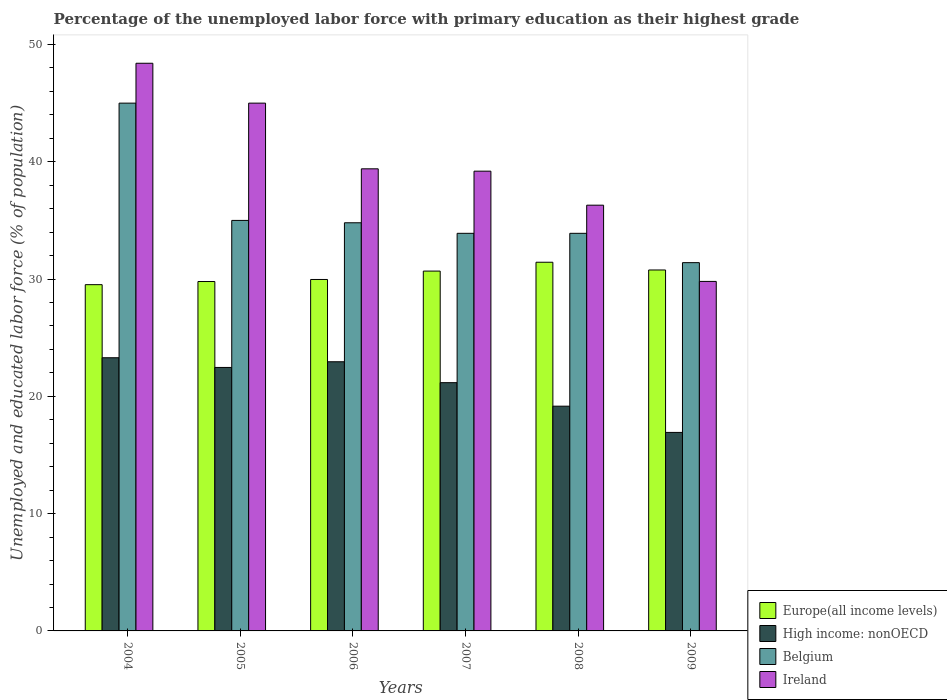Are the number of bars per tick equal to the number of legend labels?
Provide a short and direct response. Yes. Are the number of bars on each tick of the X-axis equal?
Offer a very short reply. Yes. How many bars are there on the 4th tick from the right?
Provide a short and direct response. 4. What is the label of the 3rd group of bars from the left?
Offer a very short reply. 2006. In how many cases, is the number of bars for a given year not equal to the number of legend labels?
Ensure brevity in your answer.  0. What is the percentage of the unemployed labor force with primary education in High income: nonOECD in 2004?
Your response must be concise. 23.29. Across all years, what is the maximum percentage of the unemployed labor force with primary education in High income: nonOECD?
Keep it short and to the point. 23.29. Across all years, what is the minimum percentage of the unemployed labor force with primary education in Europe(all income levels)?
Ensure brevity in your answer.  29.52. In which year was the percentage of the unemployed labor force with primary education in Ireland minimum?
Provide a succinct answer. 2009. What is the total percentage of the unemployed labor force with primary education in Belgium in the graph?
Your answer should be very brief. 214. What is the difference between the percentage of the unemployed labor force with primary education in Ireland in 2004 and that in 2008?
Your answer should be compact. 12.1. What is the difference between the percentage of the unemployed labor force with primary education in Europe(all income levels) in 2008 and the percentage of the unemployed labor force with primary education in Ireland in 2006?
Ensure brevity in your answer.  -7.97. What is the average percentage of the unemployed labor force with primary education in Ireland per year?
Keep it short and to the point. 39.68. In the year 2009, what is the difference between the percentage of the unemployed labor force with primary education in Europe(all income levels) and percentage of the unemployed labor force with primary education in Ireland?
Your response must be concise. 0.97. In how many years, is the percentage of the unemployed labor force with primary education in Europe(all income levels) greater than 46 %?
Give a very brief answer. 0. What is the ratio of the percentage of the unemployed labor force with primary education in Ireland in 2004 to that in 2005?
Offer a terse response. 1.08. Is the percentage of the unemployed labor force with primary education in High income: nonOECD in 2006 less than that in 2009?
Keep it short and to the point. No. Is the difference between the percentage of the unemployed labor force with primary education in Europe(all income levels) in 2004 and 2005 greater than the difference between the percentage of the unemployed labor force with primary education in Ireland in 2004 and 2005?
Provide a short and direct response. No. What is the difference between the highest and the second highest percentage of the unemployed labor force with primary education in Europe(all income levels)?
Offer a terse response. 0.66. What is the difference between the highest and the lowest percentage of the unemployed labor force with primary education in Ireland?
Give a very brief answer. 18.6. What does the 1st bar from the right in 2008 represents?
Keep it short and to the point. Ireland. How many bars are there?
Give a very brief answer. 24. What is the difference between two consecutive major ticks on the Y-axis?
Your answer should be compact. 10. Does the graph contain any zero values?
Provide a succinct answer. No. Does the graph contain grids?
Your answer should be compact. No. How many legend labels are there?
Make the answer very short. 4. What is the title of the graph?
Your response must be concise. Percentage of the unemployed labor force with primary education as their highest grade. What is the label or title of the X-axis?
Provide a short and direct response. Years. What is the label or title of the Y-axis?
Your answer should be very brief. Unemployed and educated labor force (% of population). What is the Unemployed and educated labor force (% of population) in Europe(all income levels) in 2004?
Your response must be concise. 29.52. What is the Unemployed and educated labor force (% of population) of High income: nonOECD in 2004?
Provide a short and direct response. 23.29. What is the Unemployed and educated labor force (% of population) of Belgium in 2004?
Your answer should be compact. 45. What is the Unemployed and educated labor force (% of population) of Ireland in 2004?
Ensure brevity in your answer.  48.4. What is the Unemployed and educated labor force (% of population) of Europe(all income levels) in 2005?
Provide a succinct answer. 29.79. What is the Unemployed and educated labor force (% of population) of High income: nonOECD in 2005?
Make the answer very short. 22.46. What is the Unemployed and educated labor force (% of population) of Belgium in 2005?
Keep it short and to the point. 35. What is the Unemployed and educated labor force (% of population) in Europe(all income levels) in 2006?
Keep it short and to the point. 29.97. What is the Unemployed and educated labor force (% of population) in High income: nonOECD in 2006?
Provide a short and direct response. 22.95. What is the Unemployed and educated labor force (% of population) in Belgium in 2006?
Make the answer very short. 34.8. What is the Unemployed and educated labor force (% of population) in Ireland in 2006?
Your answer should be compact. 39.4. What is the Unemployed and educated labor force (% of population) of Europe(all income levels) in 2007?
Offer a very short reply. 30.68. What is the Unemployed and educated labor force (% of population) of High income: nonOECD in 2007?
Your answer should be compact. 21.17. What is the Unemployed and educated labor force (% of population) of Belgium in 2007?
Provide a succinct answer. 33.9. What is the Unemployed and educated labor force (% of population) of Ireland in 2007?
Make the answer very short. 39.2. What is the Unemployed and educated labor force (% of population) of Europe(all income levels) in 2008?
Offer a terse response. 31.43. What is the Unemployed and educated labor force (% of population) of High income: nonOECD in 2008?
Give a very brief answer. 19.16. What is the Unemployed and educated labor force (% of population) in Belgium in 2008?
Make the answer very short. 33.9. What is the Unemployed and educated labor force (% of population) in Ireland in 2008?
Provide a succinct answer. 36.3. What is the Unemployed and educated labor force (% of population) in Europe(all income levels) in 2009?
Your answer should be compact. 30.77. What is the Unemployed and educated labor force (% of population) in High income: nonOECD in 2009?
Ensure brevity in your answer.  16.93. What is the Unemployed and educated labor force (% of population) of Belgium in 2009?
Your answer should be compact. 31.4. What is the Unemployed and educated labor force (% of population) of Ireland in 2009?
Your response must be concise. 29.8. Across all years, what is the maximum Unemployed and educated labor force (% of population) of Europe(all income levels)?
Your answer should be compact. 31.43. Across all years, what is the maximum Unemployed and educated labor force (% of population) of High income: nonOECD?
Provide a succinct answer. 23.29. Across all years, what is the maximum Unemployed and educated labor force (% of population) in Belgium?
Make the answer very short. 45. Across all years, what is the maximum Unemployed and educated labor force (% of population) in Ireland?
Give a very brief answer. 48.4. Across all years, what is the minimum Unemployed and educated labor force (% of population) of Europe(all income levels)?
Your response must be concise. 29.52. Across all years, what is the minimum Unemployed and educated labor force (% of population) of High income: nonOECD?
Keep it short and to the point. 16.93. Across all years, what is the minimum Unemployed and educated labor force (% of population) in Belgium?
Provide a short and direct response. 31.4. Across all years, what is the minimum Unemployed and educated labor force (% of population) in Ireland?
Provide a short and direct response. 29.8. What is the total Unemployed and educated labor force (% of population) of Europe(all income levels) in the graph?
Provide a succinct answer. 182.17. What is the total Unemployed and educated labor force (% of population) of High income: nonOECD in the graph?
Provide a short and direct response. 125.96. What is the total Unemployed and educated labor force (% of population) in Belgium in the graph?
Keep it short and to the point. 214. What is the total Unemployed and educated labor force (% of population) of Ireland in the graph?
Provide a succinct answer. 238.1. What is the difference between the Unemployed and educated labor force (% of population) in Europe(all income levels) in 2004 and that in 2005?
Your response must be concise. -0.27. What is the difference between the Unemployed and educated labor force (% of population) in High income: nonOECD in 2004 and that in 2005?
Give a very brief answer. 0.83. What is the difference between the Unemployed and educated labor force (% of population) of Belgium in 2004 and that in 2005?
Your answer should be very brief. 10. What is the difference between the Unemployed and educated labor force (% of population) of Ireland in 2004 and that in 2005?
Offer a terse response. 3.4. What is the difference between the Unemployed and educated labor force (% of population) in Europe(all income levels) in 2004 and that in 2006?
Provide a succinct answer. -0.44. What is the difference between the Unemployed and educated labor force (% of population) in High income: nonOECD in 2004 and that in 2006?
Your response must be concise. 0.34. What is the difference between the Unemployed and educated labor force (% of population) of Belgium in 2004 and that in 2006?
Offer a very short reply. 10.2. What is the difference between the Unemployed and educated labor force (% of population) in Europe(all income levels) in 2004 and that in 2007?
Your response must be concise. -1.16. What is the difference between the Unemployed and educated labor force (% of population) of High income: nonOECD in 2004 and that in 2007?
Offer a very short reply. 2.12. What is the difference between the Unemployed and educated labor force (% of population) in Belgium in 2004 and that in 2007?
Provide a succinct answer. 11.1. What is the difference between the Unemployed and educated labor force (% of population) of Europe(all income levels) in 2004 and that in 2008?
Provide a short and direct response. -1.91. What is the difference between the Unemployed and educated labor force (% of population) of High income: nonOECD in 2004 and that in 2008?
Give a very brief answer. 4.13. What is the difference between the Unemployed and educated labor force (% of population) of Belgium in 2004 and that in 2008?
Your response must be concise. 11.1. What is the difference between the Unemployed and educated labor force (% of population) of Europe(all income levels) in 2004 and that in 2009?
Offer a terse response. -1.25. What is the difference between the Unemployed and educated labor force (% of population) of High income: nonOECD in 2004 and that in 2009?
Your answer should be compact. 6.37. What is the difference between the Unemployed and educated labor force (% of population) in Ireland in 2004 and that in 2009?
Provide a succinct answer. 18.6. What is the difference between the Unemployed and educated labor force (% of population) in Europe(all income levels) in 2005 and that in 2006?
Provide a succinct answer. -0.17. What is the difference between the Unemployed and educated labor force (% of population) in High income: nonOECD in 2005 and that in 2006?
Ensure brevity in your answer.  -0.49. What is the difference between the Unemployed and educated labor force (% of population) of Ireland in 2005 and that in 2006?
Your answer should be very brief. 5.6. What is the difference between the Unemployed and educated labor force (% of population) in Europe(all income levels) in 2005 and that in 2007?
Your response must be concise. -0.89. What is the difference between the Unemployed and educated labor force (% of population) in High income: nonOECD in 2005 and that in 2007?
Your answer should be very brief. 1.3. What is the difference between the Unemployed and educated labor force (% of population) of Europe(all income levels) in 2005 and that in 2008?
Make the answer very short. -1.64. What is the difference between the Unemployed and educated labor force (% of population) in High income: nonOECD in 2005 and that in 2008?
Give a very brief answer. 3.3. What is the difference between the Unemployed and educated labor force (% of population) of Belgium in 2005 and that in 2008?
Your response must be concise. 1.1. What is the difference between the Unemployed and educated labor force (% of population) of Europe(all income levels) in 2005 and that in 2009?
Provide a succinct answer. -0.98. What is the difference between the Unemployed and educated labor force (% of population) in High income: nonOECD in 2005 and that in 2009?
Keep it short and to the point. 5.54. What is the difference between the Unemployed and educated labor force (% of population) of Belgium in 2005 and that in 2009?
Your answer should be very brief. 3.6. What is the difference between the Unemployed and educated labor force (% of population) in Europe(all income levels) in 2006 and that in 2007?
Keep it short and to the point. -0.71. What is the difference between the Unemployed and educated labor force (% of population) of High income: nonOECD in 2006 and that in 2007?
Keep it short and to the point. 1.78. What is the difference between the Unemployed and educated labor force (% of population) of Europe(all income levels) in 2006 and that in 2008?
Your answer should be compact. -1.47. What is the difference between the Unemployed and educated labor force (% of population) in High income: nonOECD in 2006 and that in 2008?
Offer a very short reply. 3.79. What is the difference between the Unemployed and educated labor force (% of population) in Ireland in 2006 and that in 2008?
Keep it short and to the point. 3.1. What is the difference between the Unemployed and educated labor force (% of population) of Europe(all income levels) in 2006 and that in 2009?
Your response must be concise. -0.81. What is the difference between the Unemployed and educated labor force (% of population) of High income: nonOECD in 2006 and that in 2009?
Provide a succinct answer. 6.02. What is the difference between the Unemployed and educated labor force (% of population) in Belgium in 2006 and that in 2009?
Provide a succinct answer. 3.4. What is the difference between the Unemployed and educated labor force (% of population) of Ireland in 2006 and that in 2009?
Give a very brief answer. 9.6. What is the difference between the Unemployed and educated labor force (% of population) of Europe(all income levels) in 2007 and that in 2008?
Provide a succinct answer. -0.75. What is the difference between the Unemployed and educated labor force (% of population) in High income: nonOECD in 2007 and that in 2008?
Give a very brief answer. 2.01. What is the difference between the Unemployed and educated labor force (% of population) of Europe(all income levels) in 2007 and that in 2009?
Offer a terse response. -0.09. What is the difference between the Unemployed and educated labor force (% of population) in High income: nonOECD in 2007 and that in 2009?
Provide a short and direct response. 4.24. What is the difference between the Unemployed and educated labor force (% of population) in Europe(all income levels) in 2008 and that in 2009?
Your answer should be very brief. 0.66. What is the difference between the Unemployed and educated labor force (% of population) of High income: nonOECD in 2008 and that in 2009?
Provide a succinct answer. 2.24. What is the difference between the Unemployed and educated labor force (% of population) of Ireland in 2008 and that in 2009?
Give a very brief answer. 6.5. What is the difference between the Unemployed and educated labor force (% of population) in Europe(all income levels) in 2004 and the Unemployed and educated labor force (% of population) in High income: nonOECD in 2005?
Ensure brevity in your answer.  7.06. What is the difference between the Unemployed and educated labor force (% of population) of Europe(all income levels) in 2004 and the Unemployed and educated labor force (% of population) of Belgium in 2005?
Offer a very short reply. -5.48. What is the difference between the Unemployed and educated labor force (% of population) in Europe(all income levels) in 2004 and the Unemployed and educated labor force (% of population) in Ireland in 2005?
Offer a terse response. -15.48. What is the difference between the Unemployed and educated labor force (% of population) of High income: nonOECD in 2004 and the Unemployed and educated labor force (% of population) of Belgium in 2005?
Offer a very short reply. -11.71. What is the difference between the Unemployed and educated labor force (% of population) of High income: nonOECD in 2004 and the Unemployed and educated labor force (% of population) of Ireland in 2005?
Offer a very short reply. -21.71. What is the difference between the Unemployed and educated labor force (% of population) in Europe(all income levels) in 2004 and the Unemployed and educated labor force (% of population) in High income: nonOECD in 2006?
Your answer should be very brief. 6.57. What is the difference between the Unemployed and educated labor force (% of population) in Europe(all income levels) in 2004 and the Unemployed and educated labor force (% of population) in Belgium in 2006?
Your answer should be very brief. -5.28. What is the difference between the Unemployed and educated labor force (% of population) of Europe(all income levels) in 2004 and the Unemployed and educated labor force (% of population) of Ireland in 2006?
Your response must be concise. -9.88. What is the difference between the Unemployed and educated labor force (% of population) of High income: nonOECD in 2004 and the Unemployed and educated labor force (% of population) of Belgium in 2006?
Offer a terse response. -11.51. What is the difference between the Unemployed and educated labor force (% of population) of High income: nonOECD in 2004 and the Unemployed and educated labor force (% of population) of Ireland in 2006?
Ensure brevity in your answer.  -16.11. What is the difference between the Unemployed and educated labor force (% of population) of Belgium in 2004 and the Unemployed and educated labor force (% of population) of Ireland in 2006?
Your answer should be compact. 5.6. What is the difference between the Unemployed and educated labor force (% of population) in Europe(all income levels) in 2004 and the Unemployed and educated labor force (% of population) in High income: nonOECD in 2007?
Make the answer very short. 8.36. What is the difference between the Unemployed and educated labor force (% of population) of Europe(all income levels) in 2004 and the Unemployed and educated labor force (% of population) of Belgium in 2007?
Make the answer very short. -4.38. What is the difference between the Unemployed and educated labor force (% of population) in Europe(all income levels) in 2004 and the Unemployed and educated labor force (% of population) in Ireland in 2007?
Your answer should be compact. -9.68. What is the difference between the Unemployed and educated labor force (% of population) in High income: nonOECD in 2004 and the Unemployed and educated labor force (% of population) in Belgium in 2007?
Your answer should be compact. -10.61. What is the difference between the Unemployed and educated labor force (% of population) in High income: nonOECD in 2004 and the Unemployed and educated labor force (% of population) in Ireland in 2007?
Make the answer very short. -15.91. What is the difference between the Unemployed and educated labor force (% of population) of Europe(all income levels) in 2004 and the Unemployed and educated labor force (% of population) of High income: nonOECD in 2008?
Provide a short and direct response. 10.36. What is the difference between the Unemployed and educated labor force (% of population) in Europe(all income levels) in 2004 and the Unemployed and educated labor force (% of population) in Belgium in 2008?
Offer a terse response. -4.38. What is the difference between the Unemployed and educated labor force (% of population) in Europe(all income levels) in 2004 and the Unemployed and educated labor force (% of population) in Ireland in 2008?
Offer a terse response. -6.78. What is the difference between the Unemployed and educated labor force (% of population) of High income: nonOECD in 2004 and the Unemployed and educated labor force (% of population) of Belgium in 2008?
Provide a succinct answer. -10.61. What is the difference between the Unemployed and educated labor force (% of population) of High income: nonOECD in 2004 and the Unemployed and educated labor force (% of population) of Ireland in 2008?
Your answer should be compact. -13.01. What is the difference between the Unemployed and educated labor force (% of population) of Europe(all income levels) in 2004 and the Unemployed and educated labor force (% of population) of High income: nonOECD in 2009?
Ensure brevity in your answer.  12.6. What is the difference between the Unemployed and educated labor force (% of population) of Europe(all income levels) in 2004 and the Unemployed and educated labor force (% of population) of Belgium in 2009?
Offer a very short reply. -1.88. What is the difference between the Unemployed and educated labor force (% of population) of Europe(all income levels) in 2004 and the Unemployed and educated labor force (% of population) of Ireland in 2009?
Your answer should be compact. -0.28. What is the difference between the Unemployed and educated labor force (% of population) of High income: nonOECD in 2004 and the Unemployed and educated labor force (% of population) of Belgium in 2009?
Provide a succinct answer. -8.11. What is the difference between the Unemployed and educated labor force (% of population) in High income: nonOECD in 2004 and the Unemployed and educated labor force (% of population) in Ireland in 2009?
Your answer should be compact. -6.51. What is the difference between the Unemployed and educated labor force (% of population) in Belgium in 2004 and the Unemployed and educated labor force (% of population) in Ireland in 2009?
Provide a succinct answer. 15.2. What is the difference between the Unemployed and educated labor force (% of population) of Europe(all income levels) in 2005 and the Unemployed and educated labor force (% of population) of High income: nonOECD in 2006?
Offer a very short reply. 6.84. What is the difference between the Unemployed and educated labor force (% of population) in Europe(all income levels) in 2005 and the Unemployed and educated labor force (% of population) in Belgium in 2006?
Provide a succinct answer. -5.01. What is the difference between the Unemployed and educated labor force (% of population) of Europe(all income levels) in 2005 and the Unemployed and educated labor force (% of population) of Ireland in 2006?
Keep it short and to the point. -9.61. What is the difference between the Unemployed and educated labor force (% of population) in High income: nonOECD in 2005 and the Unemployed and educated labor force (% of population) in Belgium in 2006?
Your answer should be very brief. -12.34. What is the difference between the Unemployed and educated labor force (% of population) in High income: nonOECD in 2005 and the Unemployed and educated labor force (% of population) in Ireland in 2006?
Offer a very short reply. -16.94. What is the difference between the Unemployed and educated labor force (% of population) of Belgium in 2005 and the Unemployed and educated labor force (% of population) of Ireland in 2006?
Ensure brevity in your answer.  -4.4. What is the difference between the Unemployed and educated labor force (% of population) of Europe(all income levels) in 2005 and the Unemployed and educated labor force (% of population) of High income: nonOECD in 2007?
Offer a very short reply. 8.62. What is the difference between the Unemployed and educated labor force (% of population) of Europe(all income levels) in 2005 and the Unemployed and educated labor force (% of population) of Belgium in 2007?
Ensure brevity in your answer.  -4.11. What is the difference between the Unemployed and educated labor force (% of population) in Europe(all income levels) in 2005 and the Unemployed and educated labor force (% of population) in Ireland in 2007?
Make the answer very short. -9.41. What is the difference between the Unemployed and educated labor force (% of population) in High income: nonOECD in 2005 and the Unemployed and educated labor force (% of population) in Belgium in 2007?
Offer a very short reply. -11.44. What is the difference between the Unemployed and educated labor force (% of population) in High income: nonOECD in 2005 and the Unemployed and educated labor force (% of population) in Ireland in 2007?
Provide a short and direct response. -16.74. What is the difference between the Unemployed and educated labor force (% of population) in Europe(all income levels) in 2005 and the Unemployed and educated labor force (% of population) in High income: nonOECD in 2008?
Make the answer very short. 10.63. What is the difference between the Unemployed and educated labor force (% of population) of Europe(all income levels) in 2005 and the Unemployed and educated labor force (% of population) of Belgium in 2008?
Keep it short and to the point. -4.11. What is the difference between the Unemployed and educated labor force (% of population) in Europe(all income levels) in 2005 and the Unemployed and educated labor force (% of population) in Ireland in 2008?
Your response must be concise. -6.51. What is the difference between the Unemployed and educated labor force (% of population) in High income: nonOECD in 2005 and the Unemployed and educated labor force (% of population) in Belgium in 2008?
Provide a succinct answer. -11.44. What is the difference between the Unemployed and educated labor force (% of population) in High income: nonOECD in 2005 and the Unemployed and educated labor force (% of population) in Ireland in 2008?
Ensure brevity in your answer.  -13.84. What is the difference between the Unemployed and educated labor force (% of population) in Belgium in 2005 and the Unemployed and educated labor force (% of population) in Ireland in 2008?
Ensure brevity in your answer.  -1.3. What is the difference between the Unemployed and educated labor force (% of population) of Europe(all income levels) in 2005 and the Unemployed and educated labor force (% of population) of High income: nonOECD in 2009?
Make the answer very short. 12.87. What is the difference between the Unemployed and educated labor force (% of population) in Europe(all income levels) in 2005 and the Unemployed and educated labor force (% of population) in Belgium in 2009?
Keep it short and to the point. -1.61. What is the difference between the Unemployed and educated labor force (% of population) in Europe(all income levels) in 2005 and the Unemployed and educated labor force (% of population) in Ireland in 2009?
Your answer should be very brief. -0.01. What is the difference between the Unemployed and educated labor force (% of population) in High income: nonOECD in 2005 and the Unemployed and educated labor force (% of population) in Belgium in 2009?
Offer a terse response. -8.94. What is the difference between the Unemployed and educated labor force (% of population) of High income: nonOECD in 2005 and the Unemployed and educated labor force (% of population) of Ireland in 2009?
Ensure brevity in your answer.  -7.34. What is the difference between the Unemployed and educated labor force (% of population) of Europe(all income levels) in 2006 and the Unemployed and educated labor force (% of population) of High income: nonOECD in 2007?
Offer a terse response. 8.8. What is the difference between the Unemployed and educated labor force (% of population) of Europe(all income levels) in 2006 and the Unemployed and educated labor force (% of population) of Belgium in 2007?
Ensure brevity in your answer.  -3.93. What is the difference between the Unemployed and educated labor force (% of population) in Europe(all income levels) in 2006 and the Unemployed and educated labor force (% of population) in Ireland in 2007?
Provide a short and direct response. -9.23. What is the difference between the Unemployed and educated labor force (% of population) of High income: nonOECD in 2006 and the Unemployed and educated labor force (% of population) of Belgium in 2007?
Give a very brief answer. -10.95. What is the difference between the Unemployed and educated labor force (% of population) in High income: nonOECD in 2006 and the Unemployed and educated labor force (% of population) in Ireland in 2007?
Provide a short and direct response. -16.25. What is the difference between the Unemployed and educated labor force (% of population) of Belgium in 2006 and the Unemployed and educated labor force (% of population) of Ireland in 2007?
Provide a short and direct response. -4.4. What is the difference between the Unemployed and educated labor force (% of population) in Europe(all income levels) in 2006 and the Unemployed and educated labor force (% of population) in High income: nonOECD in 2008?
Provide a succinct answer. 10.8. What is the difference between the Unemployed and educated labor force (% of population) in Europe(all income levels) in 2006 and the Unemployed and educated labor force (% of population) in Belgium in 2008?
Provide a succinct answer. -3.93. What is the difference between the Unemployed and educated labor force (% of population) in Europe(all income levels) in 2006 and the Unemployed and educated labor force (% of population) in Ireland in 2008?
Offer a terse response. -6.33. What is the difference between the Unemployed and educated labor force (% of population) of High income: nonOECD in 2006 and the Unemployed and educated labor force (% of population) of Belgium in 2008?
Provide a succinct answer. -10.95. What is the difference between the Unemployed and educated labor force (% of population) in High income: nonOECD in 2006 and the Unemployed and educated labor force (% of population) in Ireland in 2008?
Give a very brief answer. -13.35. What is the difference between the Unemployed and educated labor force (% of population) of Europe(all income levels) in 2006 and the Unemployed and educated labor force (% of population) of High income: nonOECD in 2009?
Provide a succinct answer. 13.04. What is the difference between the Unemployed and educated labor force (% of population) of Europe(all income levels) in 2006 and the Unemployed and educated labor force (% of population) of Belgium in 2009?
Your answer should be very brief. -1.43. What is the difference between the Unemployed and educated labor force (% of population) of Europe(all income levels) in 2006 and the Unemployed and educated labor force (% of population) of Ireland in 2009?
Make the answer very short. 0.17. What is the difference between the Unemployed and educated labor force (% of population) in High income: nonOECD in 2006 and the Unemployed and educated labor force (% of population) in Belgium in 2009?
Make the answer very short. -8.45. What is the difference between the Unemployed and educated labor force (% of population) of High income: nonOECD in 2006 and the Unemployed and educated labor force (% of population) of Ireland in 2009?
Your answer should be very brief. -6.85. What is the difference between the Unemployed and educated labor force (% of population) in Europe(all income levels) in 2007 and the Unemployed and educated labor force (% of population) in High income: nonOECD in 2008?
Keep it short and to the point. 11.52. What is the difference between the Unemployed and educated labor force (% of population) in Europe(all income levels) in 2007 and the Unemployed and educated labor force (% of population) in Belgium in 2008?
Provide a succinct answer. -3.22. What is the difference between the Unemployed and educated labor force (% of population) in Europe(all income levels) in 2007 and the Unemployed and educated labor force (% of population) in Ireland in 2008?
Make the answer very short. -5.62. What is the difference between the Unemployed and educated labor force (% of population) in High income: nonOECD in 2007 and the Unemployed and educated labor force (% of population) in Belgium in 2008?
Your answer should be very brief. -12.73. What is the difference between the Unemployed and educated labor force (% of population) of High income: nonOECD in 2007 and the Unemployed and educated labor force (% of population) of Ireland in 2008?
Ensure brevity in your answer.  -15.13. What is the difference between the Unemployed and educated labor force (% of population) of Belgium in 2007 and the Unemployed and educated labor force (% of population) of Ireland in 2008?
Make the answer very short. -2.4. What is the difference between the Unemployed and educated labor force (% of population) of Europe(all income levels) in 2007 and the Unemployed and educated labor force (% of population) of High income: nonOECD in 2009?
Keep it short and to the point. 13.75. What is the difference between the Unemployed and educated labor force (% of population) in Europe(all income levels) in 2007 and the Unemployed and educated labor force (% of population) in Belgium in 2009?
Your response must be concise. -0.72. What is the difference between the Unemployed and educated labor force (% of population) of High income: nonOECD in 2007 and the Unemployed and educated labor force (% of population) of Belgium in 2009?
Offer a very short reply. -10.23. What is the difference between the Unemployed and educated labor force (% of population) in High income: nonOECD in 2007 and the Unemployed and educated labor force (% of population) in Ireland in 2009?
Your answer should be compact. -8.63. What is the difference between the Unemployed and educated labor force (% of population) in Belgium in 2007 and the Unemployed and educated labor force (% of population) in Ireland in 2009?
Provide a succinct answer. 4.1. What is the difference between the Unemployed and educated labor force (% of population) in Europe(all income levels) in 2008 and the Unemployed and educated labor force (% of population) in High income: nonOECD in 2009?
Your response must be concise. 14.51. What is the difference between the Unemployed and educated labor force (% of population) in Europe(all income levels) in 2008 and the Unemployed and educated labor force (% of population) in Belgium in 2009?
Give a very brief answer. 0.03. What is the difference between the Unemployed and educated labor force (% of population) of Europe(all income levels) in 2008 and the Unemployed and educated labor force (% of population) of Ireland in 2009?
Offer a terse response. 1.63. What is the difference between the Unemployed and educated labor force (% of population) in High income: nonOECD in 2008 and the Unemployed and educated labor force (% of population) in Belgium in 2009?
Your answer should be very brief. -12.24. What is the difference between the Unemployed and educated labor force (% of population) in High income: nonOECD in 2008 and the Unemployed and educated labor force (% of population) in Ireland in 2009?
Offer a very short reply. -10.64. What is the average Unemployed and educated labor force (% of population) in Europe(all income levels) per year?
Provide a succinct answer. 30.36. What is the average Unemployed and educated labor force (% of population) of High income: nonOECD per year?
Give a very brief answer. 20.99. What is the average Unemployed and educated labor force (% of population) of Belgium per year?
Provide a short and direct response. 35.67. What is the average Unemployed and educated labor force (% of population) in Ireland per year?
Your response must be concise. 39.68. In the year 2004, what is the difference between the Unemployed and educated labor force (% of population) in Europe(all income levels) and Unemployed and educated labor force (% of population) in High income: nonOECD?
Provide a succinct answer. 6.23. In the year 2004, what is the difference between the Unemployed and educated labor force (% of population) of Europe(all income levels) and Unemployed and educated labor force (% of population) of Belgium?
Offer a terse response. -15.48. In the year 2004, what is the difference between the Unemployed and educated labor force (% of population) in Europe(all income levels) and Unemployed and educated labor force (% of population) in Ireland?
Provide a succinct answer. -18.88. In the year 2004, what is the difference between the Unemployed and educated labor force (% of population) in High income: nonOECD and Unemployed and educated labor force (% of population) in Belgium?
Provide a short and direct response. -21.71. In the year 2004, what is the difference between the Unemployed and educated labor force (% of population) in High income: nonOECD and Unemployed and educated labor force (% of population) in Ireland?
Your response must be concise. -25.11. In the year 2004, what is the difference between the Unemployed and educated labor force (% of population) in Belgium and Unemployed and educated labor force (% of population) in Ireland?
Make the answer very short. -3.4. In the year 2005, what is the difference between the Unemployed and educated labor force (% of population) of Europe(all income levels) and Unemployed and educated labor force (% of population) of High income: nonOECD?
Your answer should be very brief. 7.33. In the year 2005, what is the difference between the Unemployed and educated labor force (% of population) of Europe(all income levels) and Unemployed and educated labor force (% of population) of Belgium?
Give a very brief answer. -5.21. In the year 2005, what is the difference between the Unemployed and educated labor force (% of population) in Europe(all income levels) and Unemployed and educated labor force (% of population) in Ireland?
Your answer should be very brief. -15.21. In the year 2005, what is the difference between the Unemployed and educated labor force (% of population) of High income: nonOECD and Unemployed and educated labor force (% of population) of Belgium?
Give a very brief answer. -12.54. In the year 2005, what is the difference between the Unemployed and educated labor force (% of population) of High income: nonOECD and Unemployed and educated labor force (% of population) of Ireland?
Your response must be concise. -22.54. In the year 2005, what is the difference between the Unemployed and educated labor force (% of population) in Belgium and Unemployed and educated labor force (% of population) in Ireland?
Your response must be concise. -10. In the year 2006, what is the difference between the Unemployed and educated labor force (% of population) of Europe(all income levels) and Unemployed and educated labor force (% of population) of High income: nonOECD?
Ensure brevity in your answer.  7.02. In the year 2006, what is the difference between the Unemployed and educated labor force (% of population) in Europe(all income levels) and Unemployed and educated labor force (% of population) in Belgium?
Provide a short and direct response. -4.83. In the year 2006, what is the difference between the Unemployed and educated labor force (% of population) in Europe(all income levels) and Unemployed and educated labor force (% of population) in Ireland?
Offer a terse response. -9.43. In the year 2006, what is the difference between the Unemployed and educated labor force (% of population) of High income: nonOECD and Unemployed and educated labor force (% of population) of Belgium?
Your response must be concise. -11.85. In the year 2006, what is the difference between the Unemployed and educated labor force (% of population) in High income: nonOECD and Unemployed and educated labor force (% of population) in Ireland?
Your answer should be very brief. -16.45. In the year 2006, what is the difference between the Unemployed and educated labor force (% of population) in Belgium and Unemployed and educated labor force (% of population) in Ireland?
Provide a succinct answer. -4.6. In the year 2007, what is the difference between the Unemployed and educated labor force (% of population) in Europe(all income levels) and Unemployed and educated labor force (% of population) in High income: nonOECD?
Keep it short and to the point. 9.51. In the year 2007, what is the difference between the Unemployed and educated labor force (% of population) in Europe(all income levels) and Unemployed and educated labor force (% of population) in Belgium?
Your answer should be compact. -3.22. In the year 2007, what is the difference between the Unemployed and educated labor force (% of population) of Europe(all income levels) and Unemployed and educated labor force (% of population) of Ireland?
Keep it short and to the point. -8.52. In the year 2007, what is the difference between the Unemployed and educated labor force (% of population) of High income: nonOECD and Unemployed and educated labor force (% of population) of Belgium?
Give a very brief answer. -12.73. In the year 2007, what is the difference between the Unemployed and educated labor force (% of population) in High income: nonOECD and Unemployed and educated labor force (% of population) in Ireland?
Provide a short and direct response. -18.03. In the year 2007, what is the difference between the Unemployed and educated labor force (% of population) in Belgium and Unemployed and educated labor force (% of population) in Ireland?
Keep it short and to the point. -5.3. In the year 2008, what is the difference between the Unemployed and educated labor force (% of population) in Europe(all income levels) and Unemployed and educated labor force (% of population) in High income: nonOECD?
Offer a terse response. 12.27. In the year 2008, what is the difference between the Unemployed and educated labor force (% of population) in Europe(all income levels) and Unemployed and educated labor force (% of population) in Belgium?
Make the answer very short. -2.47. In the year 2008, what is the difference between the Unemployed and educated labor force (% of population) of Europe(all income levels) and Unemployed and educated labor force (% of population) of Ireland?
Give a very brief answer. -4.87. In the year 2008, what is the difference between the Unemployed and educated labor force (% of population) in High income: nonOECD and Unemployed and educated labor force (% of population) in Belgium?
Provide a succinct answer. -14.74. In the year 2008, what is the difference between the Unemployed and educated labor force (% of population) of High income: nonOECD and Unemployed and educated labor force (% of population) of Ireland?
Your response must be concise. -17.14. In the year 2009, what is the difference between the Unemployed and educated labor force (% of population) in Europe(all income levels) and Unemployed and educated labor force (% of population) in High income: nonOECD?
Keep it short and to the point. 13.85. In the year 2009, what is the difference between the Unemployed and educated labor force (% of population) of Europe(all income levels) and Unemployed and educated labor force (% of population) of Belgium?
Your answer should be very brief. -0.63. In the year 2009, what is the difference between the Unemployed and educated labor force (% of population) in Europe(all income levels) and Unemployed and educated labor force (% of population) in Ireland?
Offer a terse response. 0.97. In the year 2009, what is the difference between the Unemployed and educated labor force (% of population) of High income: nonOECD and Unemployed and educated labor force (% of population) of Belgium?
Ensure brevity in your answer.  -14.47. In the year 2009, what is the difference between the Unemployed and educated labor force (% of population) of High income: nonOECD and Unemployed and educated labor force (% of population) of Ireland?
Your answer should be compact. -12.87. What is the ratio of the Unemployed and educated labor force (% of population) of High income: nonOECD in 2004 to that in 2005?
Your answer should be compact. 1.04. What is the ratio of the Unemployed and educated labor force (% of population) of Belgium in 2004 to that in 2005?
Your response must be concise. 1.29. What is the ratio of the Unemployed and educated labor force (% of population) in Ireland in 2004 to that in 2005?
Give a very brief answer. 1.08. What is the ratio of the Unemployed and educated labor force (% of population) of Europe(all income levels) in 2004 to that in 2006?
Provide a succinct answer. 0.99. What is the ratio of the Unemployed and educated labor force (% of population) of High income: nonOECD in 2004 to that in 2006?
Ensure brevity in your answer.  1.01. What is the ratio of the Unemployed and educated labor force (% of population) in Belgium in 2004 to that in 2006?
Provide a succinct answer. 1.29. What is the ratio of the Unemployed and educated labor force (% of population) of Ireland in 2004 to that in 2006?
Your response must be concise. 1.23. What is the ratio of the Unemployed and educated labor force (% of population) of Europe(all income levels) in 2004 to that in 2007?
Provide a short and direct response. 0.96. What is the ratio of the Unemployed and educated labor force (% of population) in High income: nonOECD in 2004 to that in 2007?
Offer a very short reply. 1.1. What is the ratio of the Unemployed and educated labor force (% of population) of Belgium in 2004 to that in 2007?
Offer a terse response. 1.33. What is the ratio of the Unemployed and educated labor force (% of population) of Ireland in 2004 to that in 2007?
Make the answer very short. 1.23. What is the ratio of the Unemployed and educated labor force (% of population) of Europe(all income levels) in 2004 to that in 2008?
Your response must be concise. 0.94. What is the ratio of the Unemployed and educated labor force (% of population) of High income: nonOECD in 2004 to that in 2008?
Give a very brief answer. 1.22. What is the ratio of the Unemployed and educated labor force (% of population) in Belgium in 2004 to that in 2008?
Your response must be concise. 1.33. What is the ratio of the Unemployed and educated labor force (% of population) in Europe(all income levels) in 2004 to that in 2009?
Your answer should be very brief. 0.96. What is the ratio of the Unemployed and educated labor force (% of population) of High income: nonOECD in 2004 to that in 2009?
Offer a terse response. 1.38. What is the ratio of the Unemployed and educated labor force (% of population) in Belgium in 2004 to that in 2009?
Keep it short and to the point. 1.43. What is the ratio of the Unemployed and educated labor force (% of population) in Ireland in 2004 to that in 2009?
Your response must be concise. 1.62. What is the ratio of the Unemployed and educated labor force (% of population) in High income: nonOECD in 2005 to that in 2006?
Your answer should be compact. 0.98. What is the ratio of the Unemployed and educated labor force (% of population) of Belgium in 2005 to that in 2006?
Your answer should be compact. 1.01. What is the ratio of the Unemployed and educated labor force (% of population) in Ireland in 2005 to that in 2006?
Your response must be concise. 1.14. What is the ratio of the Unemployed and educated labor force (% of population) in High income: nonOECD in 2005 to that in 2007?
Offer a very short reply. 1.06. What is the ratio of the Unemployed and educated labor force (% of population) in Belgium in 2005 to that in 2007?
Give a very brief answer. 1.03. What is the ratio of the Unemployed and educated labor force (% of population) in Ireland in 2005 to that in 2007?
Your response must be concise. 1.15. What is the ratio of the Unemployed and educated labor force (% of population) in Europe(all income levels) in 2005 to that in 2008?
Provide a succinct answer. 0.95. What is the ratio of the Unemployed and educated labor force (% of population) of High income: nonOECD in 2005 to that in 2008?
Provide a short and direct response. 1.17. What is the ratio of the Unemployed and educated labor force (% of population) in Belgium in 2005 to that in 2008?
Offer a very short reply. 1.03. What is the ratio of the Unemployed and educated labor force (% of population) of Ireland in 2005 to that in 2008?
Give a very brief answer. 1.24. What is the ratio of the Unemployed and educated labor force (% of population) in Europe(all income levels) in 2005 to that in 2009?
Give a very brief answer. 0.97. What is the ratio of the Unemployed and educated labor force (% of population) in High income: nonOECD in 2005 to that in 2009?
Provide a succinct answer. 1.33. What is the ratio of the Unemployed and educated labor force (% of population) in Belgium in 2005 to that in 2009?
Offer a very short reply. 1.11. What is the ratio of the Unemployed and educated labor force (% of population) in Ireland in 2005 to that in 2009?
Provide a short and direct response. 1.51. What is the ratio of the Unemployed and educated labor force (% of population) in Europe(all income levels) in 2006 to that in 2007?
Ensure brevity in your answer.  0.98. What is the ratio of the Unemployed and educated labor force (% of population) in High income: nonOECD in 2006 to that in 2007?
Provide a succinct answer. 1.08. What is the ratio of the Unemployed and educated labor force (% of population) of Belgium in 2006 to that in 2007?
Give a very brief answer. 1.03. What is the ratio of the Unemployed and educated labor force (% of population) in Ireland in 2006 to that in 2007?
Your answer should be very brief. 1.01. What is the ratio of the Unemployed and educated labor force (% of population) of Europe(all income levels) in 2006 to that in 2008?
Make the answer very short. 0.95. What is the ratio of the Unemployed and educated labor force (% of population) in High income: nonOECD in 2006 to that in 2008?
Your answer should be compact. 1.2. What is the ratio of the Unemployed and educated labor force (% of population) of Belgium in 2006 to that in 2008?
Provide a short and direct response. 1.03. What is the ratio of the Unemployed and educated labor force (% of population) in Ireland in 2006 to that in 2008?
Your response must be concise. 1.09. What is the ratio of the Unemployed and educated labor force (% of population) of Europe(all income levels) in 2006 to that in 2009?
Keep it short and to the point. 0.97. What is the ratio of the Unemployed and educated labor force (% of population) of High income: nonOECD in 2006 to that in 2009?
Give a very brief answer. 1.36. What is the ratio of the Unemployed and educated labor force (% of population) in Belgium in 2006 to that in 2009?
Your answer should be very brief. 1.11. What is the ratio of the Unemployed and educated labor force (% of population) of Ireland in 2006 to that in 2009?
Make the answer very short. 1.32. What is the ratio of the Unemployed and educated labor force (% of population) in High income: nonOECD in 2007 to that in 2008?
Your answer should be very brief. 1.1. What is the ratio of the Unemployed and educated labor force (% of population) of Belgium in 2007 to that in 2008?
Your answer should be very brief. 1. What is the ratio of the Unemployed and educated labor force (% of population) in Ireland in 2007 to that in 2008?
Make the answer very short. 1.08. What is the ratio of the Unemployed and educated labor force (% of population) of High income: nonOECD in 2007 to that in 2009?
Provide a short and direct response. 1.25. What is the ratio of the Unemployed and educated labor force (% of population) of Belgium in 2007 to that in 2009?
Provide a short and direct response. 1.08. What is the ratio of the Unemployed and educated labor force (% of population) of Ireland in 2007 to that in 2009?
Your answer should be very brief. 1.32. What is the ratio of the Unemployed and educated labor force (% of population) of Europe(all income levels) in 2008 to that in 2009?
Offer a terse response. 1.02. What is the ratio of the Unemployed and educated labor force (% of population) of High income: nonOECD in 2008 to that in 2009?
Make the answer very short. 1.13. What is the ratio of the Unemployed and educated labor force (% of population) in Belgium in 2008 to that in 2009?
Offer a very short reply. 1.08. What is the ratio of the Unemployed and educated labor force (% of population) of Ireland in 2008 to that in 2009?
Keep it short and to the point. 1.22. What is the difference between the highest and the second highest Unemployed and educated labor force (% of population) of Europe(all income levels)?
Provide a short and direct response. 0.66. What is the difference between the highest and the second highest Unemployed and educated labor force (% of population) of High income: nonOECD?
Your answer should be compact. 0.34. What is the difference between the highest and the second highest Unemployed and educated labor force (% of population) in Ireland?
Ensure brevity in your answer.  3.4. What is the difference between the highest and the lowest Unemployed and educated labor force (% of population) in Europe(all income levels)?
Your response must be concise. 1.91. What is the difference between the highest and the lowest Unemployed and educated labor force (% of population) in High income: nonOECD?
Make the answer very short. 6.37. 